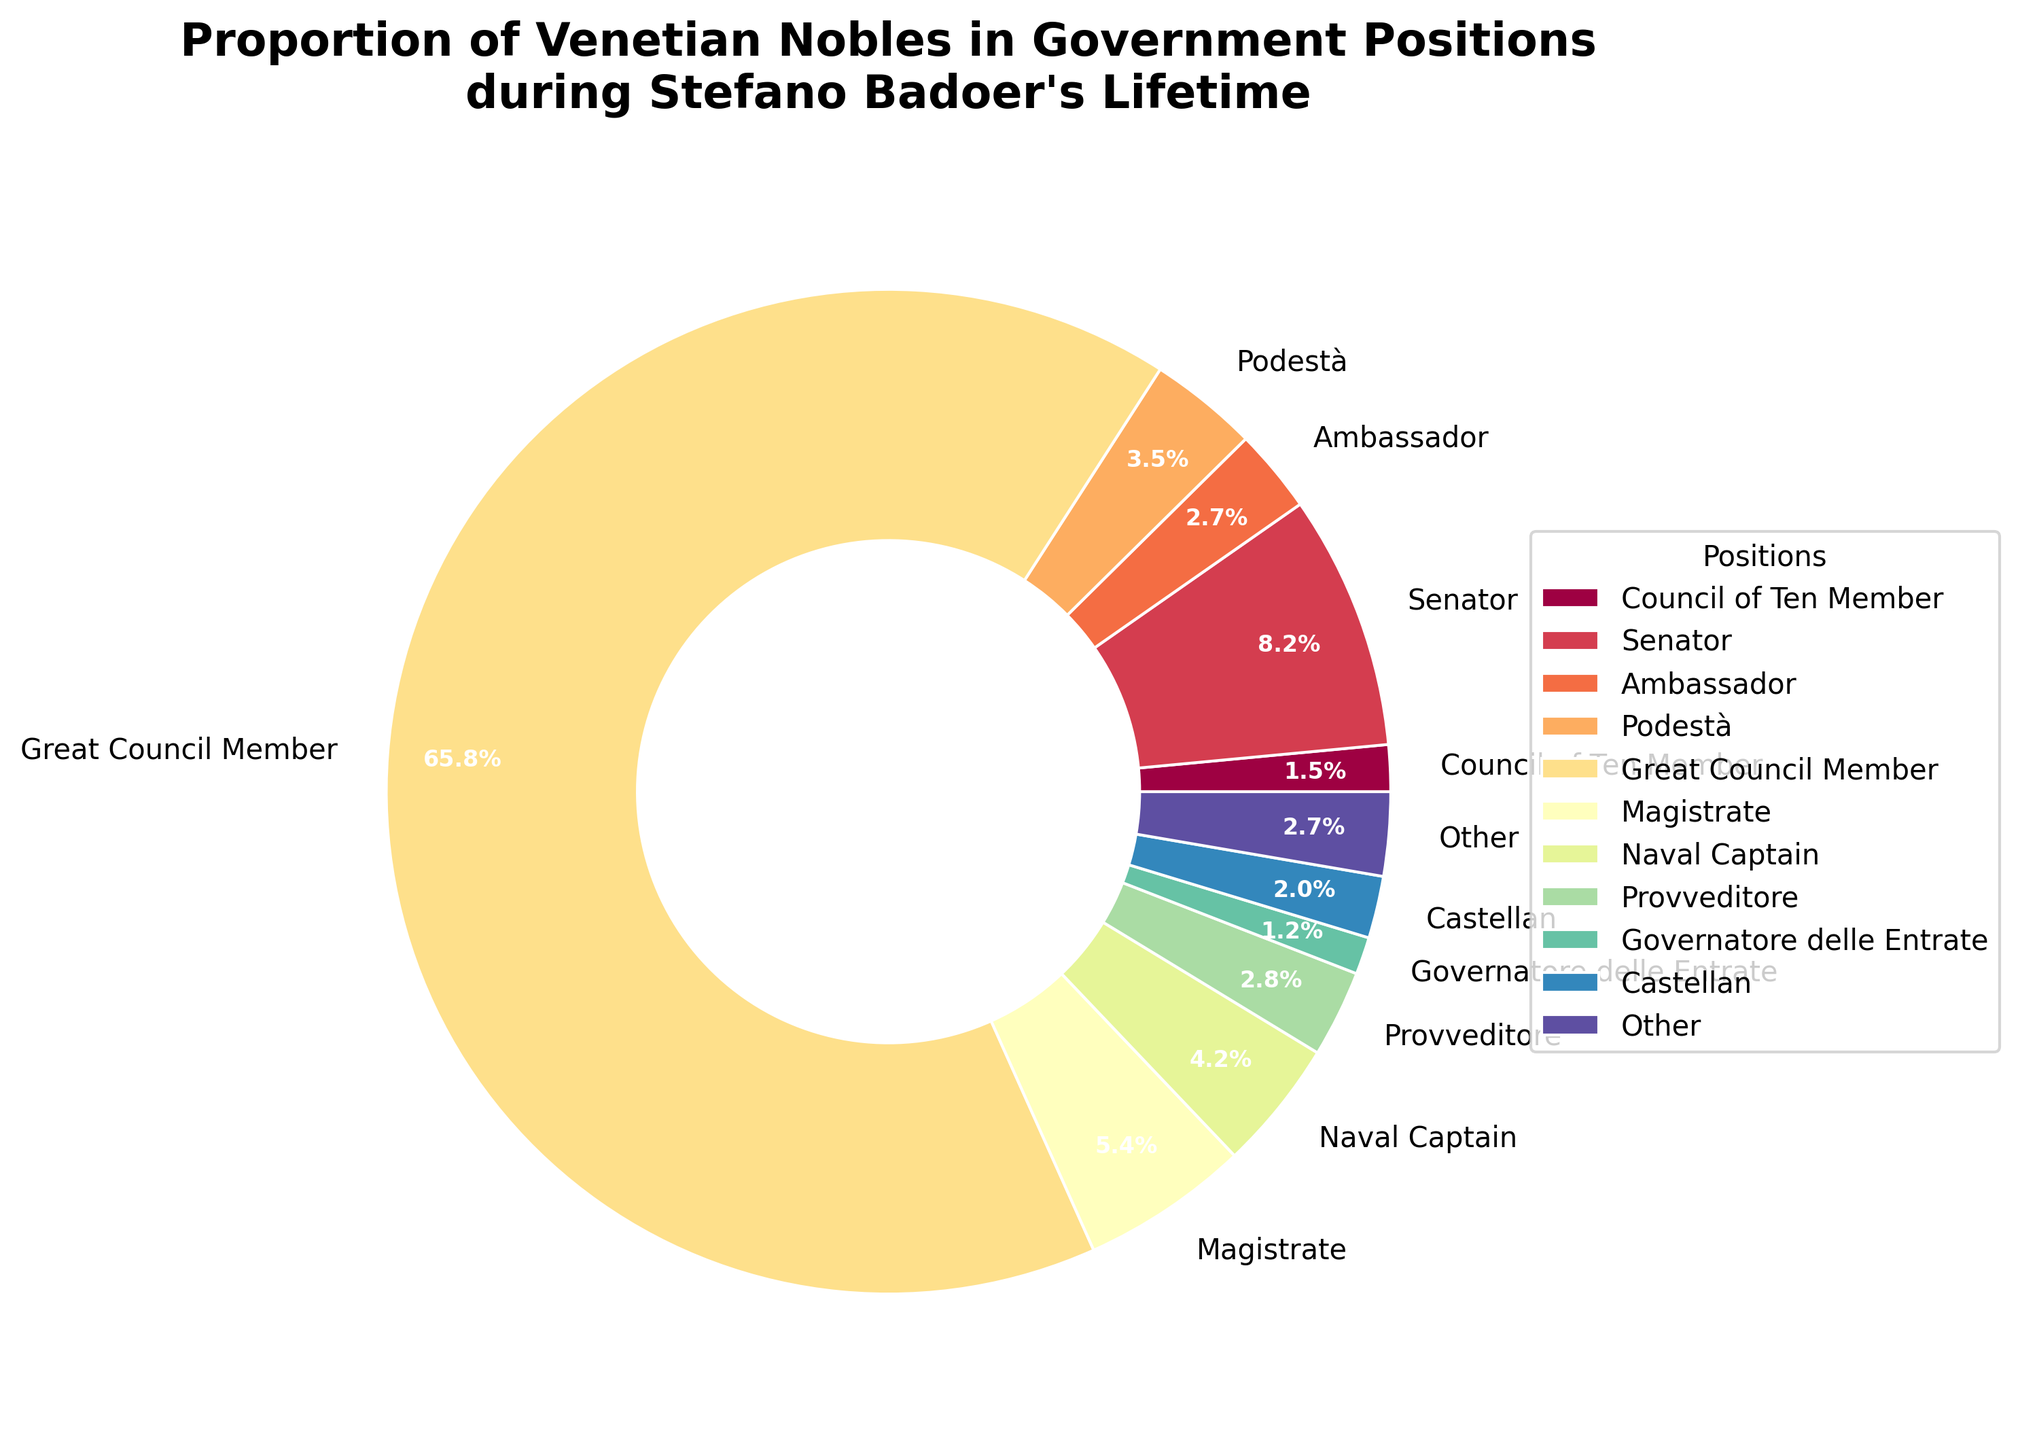Which government position has the largest proportion of Venetian nobles? The figure shows that "Great Council Member" has the largest wedge in the pie chart, indicating it has the highest percentage of Venetian nobles.
Answer: Great Council Member What is the combined percentage of Venetian nobles in the Doge, Procurator of San Marco, and Ambassador positions? Referring to the pie chart, the percentages are 0.1% for Doge, 0.3% for Procurator of San Marco, and 2.7% for Ambassador. Adding these together gives 0.1 + 0.3 + 2.7 = 3.1%.
Answer: 3.1% How many positions have a smaller percentage than the Ducal Councilor position? The pie chart legend indicates that Ducal Councilor has a percentage of 0.6%. Comparing this with other positions: Doge (0.1%), Procurator of San Marco (0.3%), Inquisitor of State (0.3%), and Avogador de Comun (0.5%) are all smaller. Thus, there are 4 positions with a smaller percentage.
Answer: 4 Which position, according to the pie chart, closely matches the color of the "Podestà" segment? Observing the colors in the pie chart, the position "Ambassador" has a color that is closest to the color of the "Podestà" segment. Both have similar shades in the spectral color scheme used.
Answer: Ambassador Is the proportion of Venetians in the Great Council Member role more than 20 times the proportion in the Senator role? The Great Council Member percentage is 65.8%, and the Senator percentage is 8.2%. Dividing 65.8 by 8.2 gives approximately 8.02, which is less than 20. So, the proportion is not more than 20 times.
Answer: No How does the proportion of Magistrates compare to Naval Captains? By comparing the pie chart segments, we see that Magistrates constitute 5.4% while Naval Captains account for 4.2%. Thus, Magistrates have a higher proportion than Naval Captains.
Answer: Magistrates have a higher proportion What is the total percentage of Venetian nobles in roles categorized under "Other"? According to the pie chart, "Other" covers positions with less than 1% each. Adding these, which include Doge (0.1%), Procurator of San Marco (0.3%), Inquisitor of State (0.3%), Avogador de Comun (0.5%), and Castallan (2.0%), results in the total of 0.1+0.3+0.3+0.5+2.0 = 3.2%.
Answer: 3.2% What is the difference in percentage between Provveditore and Savio Grande positions? From the pie chart, the Provveditore role has 2.8% while Savio Grande has 0.9%. Subtracting these, we get 2.8 - 0.9 = 1.9%.
Answer: 1.9% Among the listed roles, which one has a percentage closest to that of the Governatore delle Entrate? By comparing the proportions, the position with 1.5% for Council of Ten closely matches the Governatore delle Entrate's 1.2% when rounded.
Answer: Council of Ten Member 